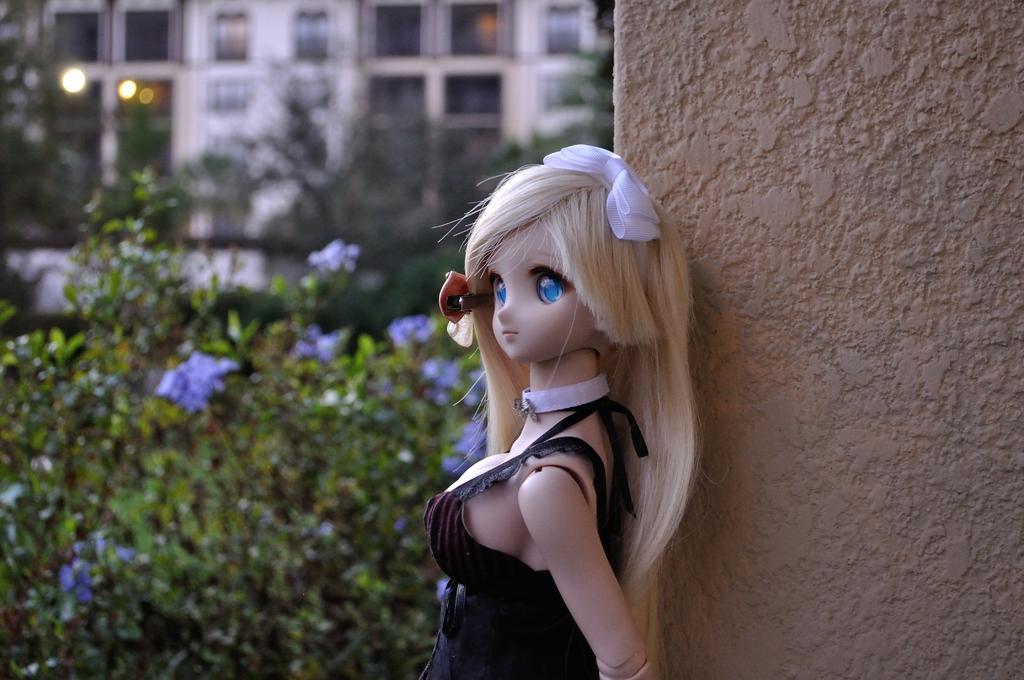Describe this image in one or two sentences. In this picture I can see the toy on the right side. I can see the wall on the right side. I can see the plants on the left side. I can see the buildings in the background. 